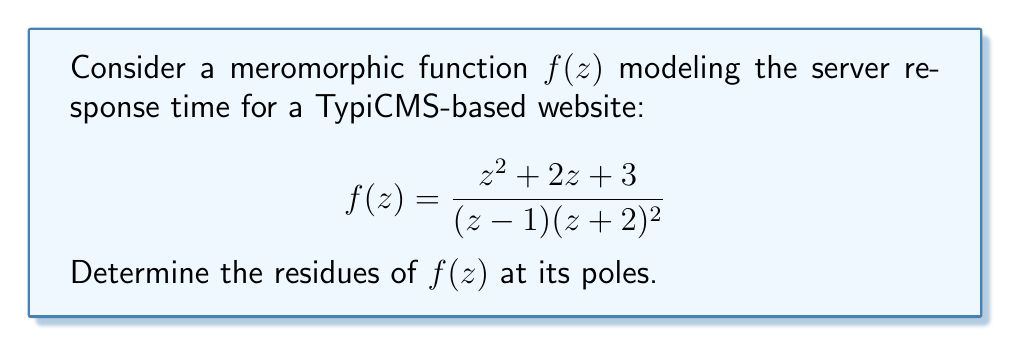Can you solve this math problem? To find the residues of $f(z)$, we need to identify its poles and calculate the residue at each pole.

1. Identify the poles:
   The poles of $f(z)$ occur at $z = 1$ and $z = -2$.
   
   - $z = 1$ is a simple pole (order 1)
   - $z = -2$ is a double pole (order 2)

2. Calculate the residue at $z = 1$ (simple pole):
   For a simple pole, we can use the formula:
   $$\text{Res}(f, 1) = \lim_{z \to 1} (z-1)f(z)$$
   
   $$\begin{align}
   \text{Res}(f, 1) &= \lim_{z \to 1} (z-1)\frac{z^2 + 2z + 3}{(z - 1)(z + 2)^2} \\
   &= \lim_{z \to 1} \frac{z^2 + 2z + 3}{(z + 2)^2} \\
   &= \frac{1^2 + 2(1) + 3}{(1 + 2)^2} \\
   &= \frac{6}{9} = \frac{2}{3}
   \end{align}$$

3. Calculate the residue at $z = -2$ (double pole):
   For a double pole, we use the formula:
   $$\text{Res}(f, -2) = \lim_{z \to -2} \frac{d}{dz}[(z+2)^2f(z)]$$
   
   $$\begin{align}
   \text{Res}(f, -2) &= \lim_{z \to -2} \frac{d}{dz}\left[(z+2)^2\frac{z^2 + 2z + 3}{(z - 1)(z + 2)^2}\right] \\
   &= \lim_{z \to -2} \frac{d}{dz}\left[\frac{z^2 + 2z + 3}{z - 1}\right] \\
   &= \lim_{z \to -2} \frac{(z-1)(2z+2) - (z^2+2z+3)(-1)}{(z-1)^2} \\
   &= \lim_{z \to -2} \frac{2z^2 - 2 + z^2 + 2z + 3}{(z-1)^2} \\
   &= \lim_{z \to -2} \frac{3z^2 + 2z + 1}{(z-1)^2} \\
   &= \frac{3(-2)^2 + 2(-2) + 1}{(-2-1)^2} \\
   &= \frac{12 - 4 + 1}{9} = 1
   \end{align}$$
Answer: The residues of $f(z)$ are:
$$\text{Res}(f, 1) = \frac{2}{3}$$ and $$\text{Res}(f, -2) = 1$$ 